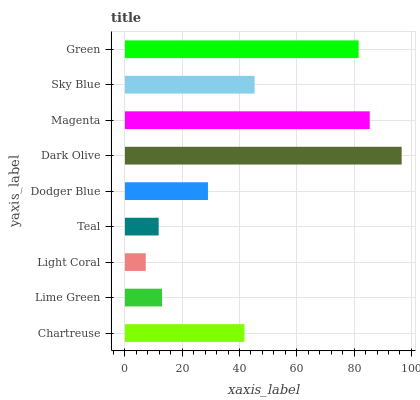Is Light Coral the minimum?
Answer yes or no. Yes. Is Dark Olive the maximum?
Answer yes or no. Yes. Is Lime Green the minimum?
Answer yes or no. No. Is Lime Green the maximum?
Answer yes or no. No. Is Chartreuse greater than Lime Green?
Answer yes or no. Yes. Is Lime Green less than Chartreuse?
Answer yes or no. Yes. Is Lime Green greater than Chartreuse?
Answer yes or no. No. Is Chartreuse less than Lime Green?
Answer yes or no. No. Is Chartreuse the high median?
Answer yes or no. Yes. Is Chartreuse the low median?
Answer yes or no. Yes. Is Dodger Blue the high median?
Answer yes or no. No. Is Teal the low median?
Answer yes or no. No. 